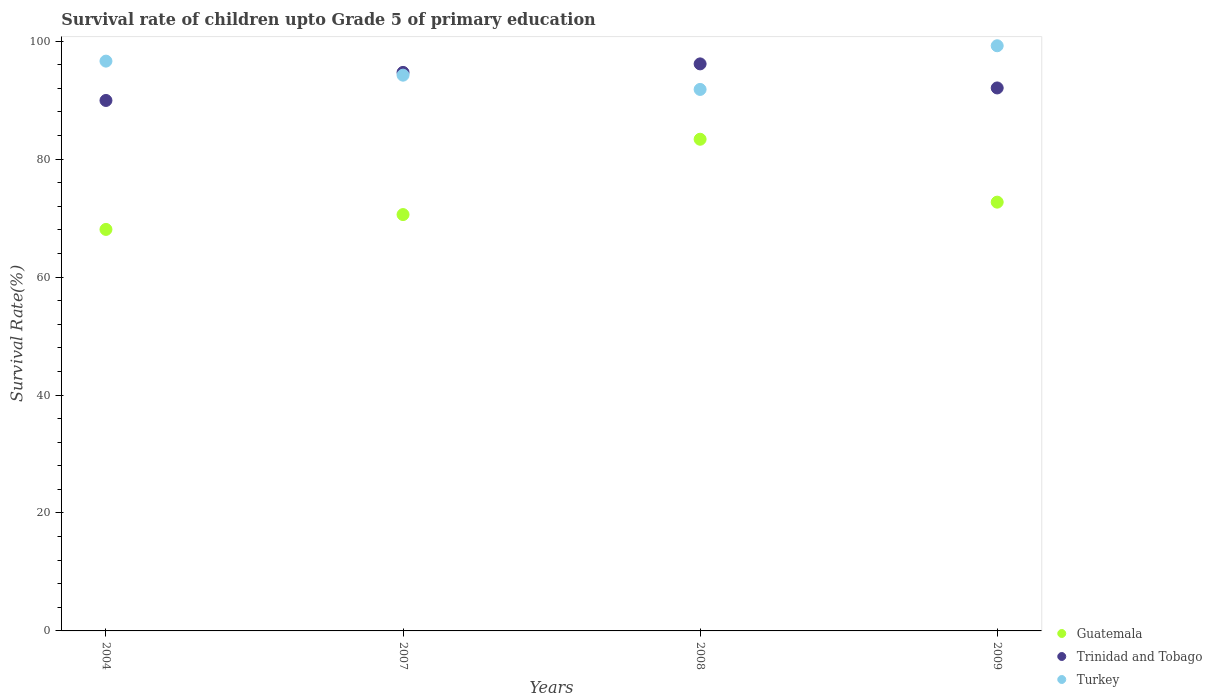How many different coloured dotlines are there?
Provide a short and direct response. 3. What is the survival rate of children in Turkey in 2007?
Ensure brevity in your answer.  94.23. Across all years, what is the maximum survival rate of children in Trinidad and Tobago?
Provide a short and direct response. 96.14. Across all years, what is the minimum survival rate of children in Turkey?
Keep it short and to the point. 91.81. In which year was the survival rate of children in Trinidad and Tobago minimum?
Give a very brief answer. 2004. What is the total survival rate of children in Trinidad and Tobago in the graph?
Your response must be concise. 372.86. What is the difference between the survival rate of children in Guatemala in 2004 and that in 2008?
Make the answer very short. -15.29. What is the difference between the survival rate of children in Guatemala in 2004 and the survival rate of children in Trinidad and Tobago in 2007?
Give a very brief answer. -26.63. What is the average survival rate of children in Turkey per year?
Ensure brevity in your answer.  95.47. In the year 2007, what is the difference between the survival rate of children in Trinidad and Tobago and survival rate of children in Turkey?
Your answer should be very brief. 0.47. What is the ratio of the survival rate of children in Trinidad and Tobago in 2008 to that in 2009?
Ensure brevity in your answer.  1.04. Is the survival rate of children in Trinidad and Tobago in 2008 less than that in 2009?
Your answer should be very brief. No. What is the difference between the highest and the second highest survival rate of children in Turkey?
Keep it short and to the point. 2.61. What is the difference between the highest and the lowest survival rate of children in Trinidad and Tobago?
Offer a terse response. 6.2. Is the sum of the survival rate of children in Guatemala in 2008 and 2009 greater than the maximum survival rate of children in Turkey across all years?
Provide a short and direct response. Yes. Is it the case that in every year, the sum of the survival rate of children in Turkey and survival rate of children in Trinidad and Tobago  is greater than the survival rate of children in Guatemala?
Give a very brief answer. Yes. Is the survival rate of children in Guatemala strictly greater than the survival rate of children in Turkey over the years?
Your response must be concise. No. Is the survival rate of children in Guatemala strictly less than the survival rate of children in Trinidad and Tobago over the years?
Your answer should be very brief. Yes. How many dotlines are there?
Offer a very short reply. 3. Are the values on the major ticks of Y-axis written in scientific E-notation?
Provide a short and direct response. No. Does the graph contain any zero values?
Make the answer very short. No. How many legend labels are there?
Your response must be concise. 3. What is the title of the graph?
Your answer should be compact. Survival rate of children upto Grade 5 of primary education. Does "Sub-Saharan Africa (developing only)" appear as one of the legend labels in the graph?
Offer a terse response. No. What is the label or title of the X-axis?
Your response must be concise. Years. What is the label or title of the Y-axis?
Keep it short and to the point. Survival Rate(%). What is the Survival Rate(%) of Guatemala in 2004?
Your answer should be compact. 68.08. What is the Survival Rate(%) of Trinidad and Tobago in 2004?
Ensure brevity in your answer.  89.94. What is the Survival Rate(%) of Turkey in 2004?
Provide a short and direct response. 96.61. What is the Survival Rate(%) of Guatemala in 2007?
Keep it short and to the point. 70.59. What is the Survival Rate(%) in Trinidad and Tobago in 2007?
Give a very brief answer. 94.7. What is the Survival Rate(%) of Turkey in 2007?
Offer a very short reply. 94.23. What is the Survival Rate(%) of Guatemala in 2008?
Make the answer very short. 83.37. What is the Survival Rate(%) of Trinidad and Tobago in 2008?
Offer a terse response. 96.14. What is the Survival Rate(%) in Turkey in 2008?
Ensure brevity in your answer.  91.81. What is the Survival Rate(%) in Guatemala in 2009?
Your answer should be compact. 72.7. What is the Survival Rate(%) of Trinidad and Tobago in 2009?
Provide a succinct answer. 92.07. What is the Survival Rate(%) in Turkey in 2009?
Ensure brevity in your answer.  99.22. Across all years, what is the maximum Survival Rate(%) in Guatemala?
Keep it short and to the point. 83.37. Across all years, what is the maximum Survival Rate(%) of Trinidad and Tobago?
Your answer should be compact. 96.14. Across all years, what is the maximum Survival Rate(%) of Turkey?
Offer a very short reply. 99.22. Across all years, what is the minimum Survival Rate(%) of Guatemala?
Offer a terse response. 68.08. Across all years, what is the minimum Survival Rate(%) of Trinidad and Tobago?
Keep it short and to the point. 89.94. Across all years, what is the minimum Survival Rate(%) of Turkey?
Provide a short and direct response. 91.81. What is the total Survival Rate(%) of Guatemala in the graph?
Your response must be concise. 294.74. What is the total Survival Rate(%) in Trinidad and Tobago in the graph?
Ensure brevity in your answer.  372.86. What is the total Survival Rate(%) of Turkey in the graph?
Your response must be concise. 381.88. What is the difference between the Survival Rate(%) of Guatemala in 2004 and that in 2007?
Offer a terse response. -2.52. What is the difference between the Survival Rate(%) in Trinidad and Tobago in 2004 and that in 2007?
Keep it short and to the point. -4.76. What is the difference between the Survival Rate(%) in Turkey in 2004 and that in 2007?
Provide a short and direct response. 2.38. What is the difference between the Survival Rate(%) in Guatemala in 2004 and that in 2008?
Ensure brevity in your answer.  -15.29. What is the difference between the Survival Rate(%) in Trinidad and Tobago in 2004 and that in 2008?
Keep it short and to the point. -6.2. What is the difference between the Survival Rate(%) of Turkey in 2004 and that in 2008?
Provide a succinct answer. 4.8. What is the difference between the Survival Rate(%) of Guatemala in 2004 and that in 2009?
Make the answer very short. -4.62. What is the difference between the Survival Rate(%) in Trinidad and Tobago in 2004 and that in 2009?
Your answer should be compact. -2.12. What is the difference between the Survival Rate(%) of Turkey in 2004 and that in 2009?
Provide a succinct answer. -2.61. What is the difference between the Survival Rate(%) in Guatemala in 2007 and that in 2008?
Ensure brevity in your answer.  -12.77. What is the difference between the Survival Rate(%) in Trinidad and Tobago in 2007 and that in 2008?
Offer a terse response. -1.44. What is the difference between the Survival Rate(%) of Turkey in 2007 and that in 2008?
Offer a very short reply. 2.42. What is the difference between the Survival Rate(%) in Guatemala in 2007 and that in 2009?
Your response must be concise. -2.11. What is the difference between the Survival Rate(%) of Trinidad and Tobago in 2007 and that in 2009?
Provide a succinct answer. 2.64. What is the difference between the Survival Rate(%) of Turkey in 2007 and that in 2009?
Give a very brief answer. -4.99. What is the difference between the Survival Rate(%) of Guatemala in 2008 and that in 2009?
Give a very brief answer. 10.67. What is the difference between the Survival Rate(%) in Trinidad and Tobago in 2008 and that in 2009?
Your answer should be very brief. 4.08. What is the difference between the Survival Rate(%) of Turkey in 2008 and that in 2009?
Give a very brief answer. -7.41. What is the difference between the Survival Rate(%) of Guatemala in 2004 and the Survival Rate(%) of Trinidad and Tobago in 2007?
Ensure brevity in your answer.  -26.63. What is the difference between the Survival Rate(%) in Guatemala in 2004 and the Survival Rate(%) in Turkey in 2007?
Your response must be concise. -26.15. What is the difference between the Survival Rate(%) of Trinidad and Tobago in 2004 and the Survival Rate(%) of Turkey in 2007?
Provide a succinct answer. -4.29. What is the difference between the Survival Rate(%) of Guatemala in 2004 and the Survival Rate(%) of Trinidad and Tobago in 2008?
Offer a terse response. -28.07. What is the difference between the Survival Rate(%) of Guatemala in 2004 and the Survival Rate(%) of Turkey in 2008?
Provide a short and direct response. -23.74. What is the difference between the Survival Rate(%) of Trinidad and Tobago in 2004 and the Survival Rate(%) of Turkey in 2008?
Provide a short and direct response. -1.87. What is the difference between the Survival Rate(%) of Guatemala in 2004 and the Survival Rate(%) of Trinidad and Tobago in 2009?
Provide a succinct answer. -23.99. What is the difference between the Survival Rate(%) of Guatemala in 2004 and the Survival Rate(%) of Turkey in 2009?
Provide a succinct answer. -31.14. What is the difference between the Survival Rate(%) of Trinidad and Tobago in 2004 and the Survival Rate(%) of Turkey in 2009?
Offer a terse response. -9.28. What is the difference between the Survival Rate(%) in Guatemala in 2007 and the Survival Rate(%) in Trinidad and Tobago in 2008?
Your answer should be very brief. -25.55. What is the difference between the Survival Rate(%) in Guatemala in 2007 and the Survival Rate(%) in Turkey in 2008?
Ensure brevity in your answer.  -21.22. What is the difference between the Survival Rate(%) of Trinidad and Tobago in 2007 and the Survival Rate(%) of Turkey in 2008?
Provide a short and direct response. 2.89. What is the difference between the Survival Rate(%) in Guatemala in 2007 and the Survival Rate(%) in Trinidad and Tobago in 2009?
Offer a terse response. -21.47. What is the difference between the Survival Rate(%) in Guatemala in 2007 and the Survival Rate(%) in Turkey in 2009?
Make the answer very short. -28.62. What is the difference between the Survival Rate(%) in Trinidad and Tobago in 2007 and the Survival Rate(%) in Turkey in 2009?
Keep it short and to the point. -4.52. What is the difference between the Survival Rate(%) in Guatemala in 2008 and the Survival Rate(%) in Trinidad and Tobago in 2009?
Ensure brevity in your answer.  -8.7. What is the difference between the Survival Rate(%) in Guatemala in 2008 and the Survival Rate(%) in Turkey in 2009?
Keep it short and to the point. -15.85. What is the difference between the Survival Rate(%) of Trinidad and Tobago in 2008 and the Survival Rate(%) of Turkey in 2009?
Ensure brevity in your answer.  -3.07. What is the average Survival Rate(%) in Guatemala per year?
Provide a short and direct response. 73.68. What is the average Survival Rate(%) of Trinidad and Tobago per year?
Your answer should be very brief. 93.21. What is the average Survival Rate(%) in Turkey per year?
Your answer should be compact. 95.47. In the year 2004, what is the difference between the Survival Rate(%) in Guatemala and Survival Rate(%) in Trinidad and Tobago?
Ensure brevity in your answer.  -21.87. In the year 2004, what is the difference between the Survival Rate(%) of Guatemala and Survival Rate(%) of Turkey?
Keep it short and to the point. -28.54. In the year 2004, what is the difference between the Survival Rate(%) of Trinidad and Tobago and Survival Rate(%) of Turkey?
Give a very brief answer. -6.67. In the year 2007, what is the difference between the Survival Rate(%) in Guatemala and Survival Rate(%) in Trinidad and Tobago?
Give a very brief answer. -24.11. In the year 2007, what is the difference between the Survival Rate(%) of Guatemala and Survival Rate(%) of Turkey?
Give a very brief answer. -23.64. In the year 2007, what is the difference between the Survival Rate(%) in Trinidad and Tobago and Survival Rate(%) in Turkey?
Give a very brief answer. 0.47. In the year 2008, what is the difference between the Survival Rate(%) in Guatemala and Survival Rate(%) in Trinidad and Tobago?
Offer a terse response. -12.78. In the year 2008, what is the difference between the Survival Rate(%) in Guatemala and Survival Rate(%) in Turkey?
Offer a terse response. -8.45. In the year 2008, what is the difference between the Survival Rate(%) of Trinidad and Tobago and Survival Rate(%) of Turkey?
Make the answer very short. 4.33. In the year 2009, what is the difference between the Survival Rate(%) of Guatemala and Survival Rate(%) of Trinidad and Tobago?
Your response must be concise. -19.36. In the year 2009, what is the difference between the Survival Rate(%) in Guatemala and Survival Rate(%) in Turkey?
Give a very brief answer. -26.52. In the year 2009, what is the difference between the Survival Rate(%) in Trinidad and Tobago and Survival Rate(%) in Turkey?
Your answer should be very brief. -7.15. What is the ratio of the Survival Rate(%) in Trinidad and Tobago in 2004 to that in 2007?
Your answer should be compact. 0.95. What is the ratio of the Survival Rate(%) of Turkey in 2004 to that in 2007?
Ensure brevity in your answer.  1.03. What is the ratio of the Survival Rate(%) in Guatemala in 2004 to that in 2008?
Make the answer very short. 0.82. What is the ratio of the Survival Rate(%) of Trinidad and Tobago in 2004 to that in 2008?
Provide a short and direct response. 0.94. What is the ratio of the Survival Rate(%) in Turkey in 2004 to that in 2008?
Ensure brevity in your answer.  1.05. What is the ratio of the Survival Rate(%) of Guatemala in 2004 to that in 2009?
Keep it short and to the point. 0.94. What is the ratio of the Survival Rate(%) in Trinidad and Tobago in 2004 to that in 2009?
Provide a short and direct response. 0.98. What is the ratio of the Survival Rate(%) of Turkey in 2004 to that in 2009?
Offer a very short reply. 0.97. What is the ratio of the Survival Rate(%) in Guatemala in 2007 to that in 2008?
Ensure brevity in your answer.  0.85. What is the ratio of the Survival Rate(%) in Trinidad and Tobago in 2007 to that in 2008?
Offer a terse response. 0.98. What is the ratio of the Survival Rate(%) of Turkey in 2007 to that in 2008?
Make the answer very short. 1.03. What is the ratio of the Survival Rate(%) in Guatemala in 2007 to that in 2009?
Ensure brevity in your answer.  0.97. What is the ratio of the Survival Rate(%) in Trinidad and Tobago in 2007 to that in 2009?
Your response must be concise. 1.03. What is the ratio of the Survival Rate(%) of Turkey in 2007 to that in 2009?
Offer a very short reply. 0.95. What is the ratio of the Survival Rate(%) of Guatemala in 2008 to that in 2009?
Keep it short and to the point. 1.15. What is the ratio of the Survival Rate(%) of Trinidad and Tobago in 2008 to that in 2009?
Offer a terse response. 1.04. What is the ratio of the Survival Rate(%) of Turkey in 2008 to that in 2009?
Keep it short and to the point. 0.93. What is the difference between the highest and the second highest Survival Rate(%) in Guatemala?
Offer a terse response. 10.67. What is the difference between the highest and the second highest Survival Rate(%) in Trinidad and Tobago?
Your answer should be very brief. 1.44. What is the difference between the highest and the second highest Survival Rate(%) in Turkey?
Make the answer very short. 2.61. What is the difference between the highest and the lowest Survival Rate(%) in Guatemala?
Your answer should be compact. 15.29. What is the difference between the highest and the lowest Survival Rate(%) in Trinidad and Tobago?
Keep it short and to the point. 6.2. What is the difference between the highest and the lowest Survival Rate(%) of Turkey?
Offer a terse response. 7.41. 